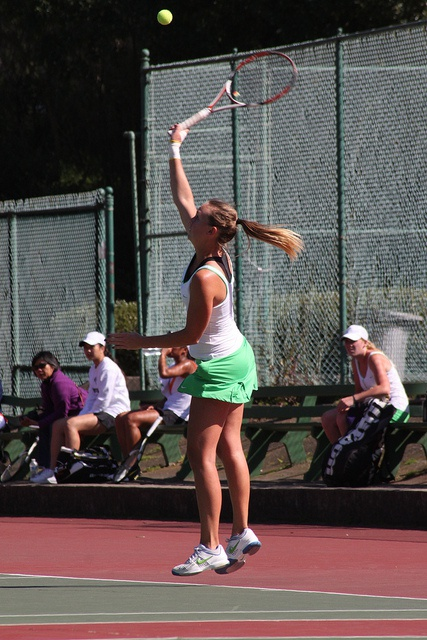Describe the objects in this image and their specific colors. I can see people in black, maroon, white, and brown tones, bench in black, gray, and darkgreen tones, chair in black and gray tones, people in black, lavender, and purple tones, and people in black, lavender, maroon, and lightpink tones in this image. 